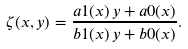Convert formula to latex. <formula><loc_0><loc_0><loc_500><loc_500>\zeta ( x , y ) = \frac { a 1 ( x ) \, y + a 0 ( x ) } { b 1 ( x ) \, y + b 0 ( x ) } .</formula> 